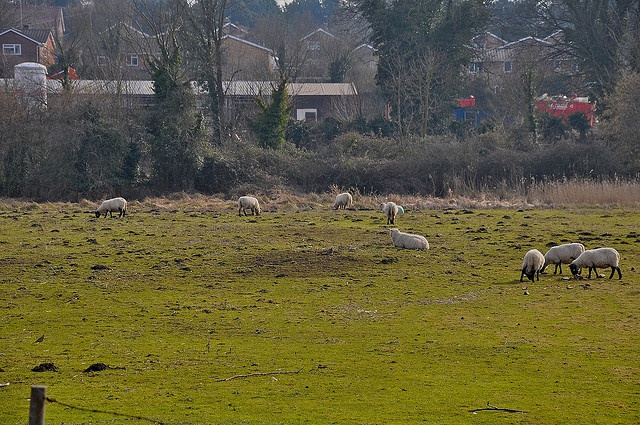Describe the objects in this image and their specific colors. I can see sheep in gray, black, and darkgray tones, sheep in gray and black tones, sheep in gray, black, olive, and darkgray tones, sheep in gray, darkgray, black, and lightgray tones, and sheep in gray, black, darkgray, and lightgray tones in this image. 